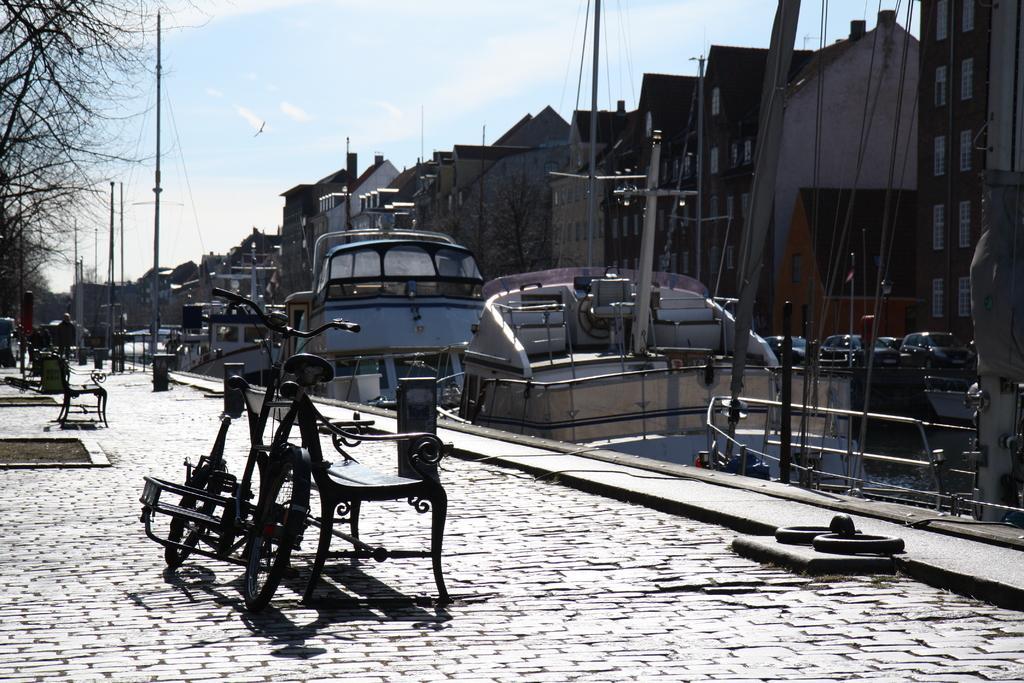How would you summarize this image in a sentence or two? In the image we can see there are many buildings and these are the window of the building. There are even may boats. Here we can see a bicycle, bench, footpath, pole, trees and a cloudy pale blue sky. We can even see a bird, flying in the sky. 